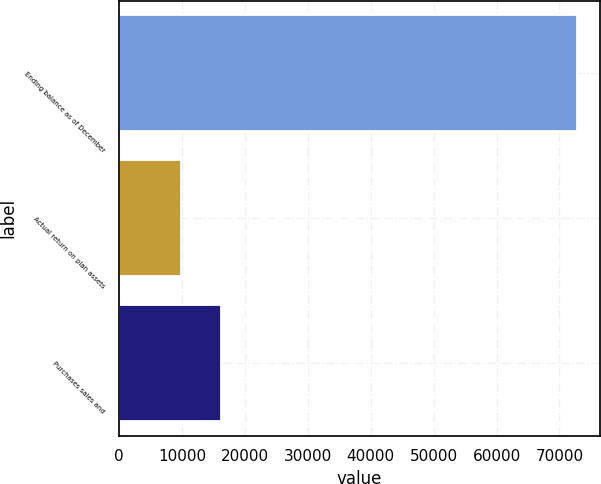Convert chart to OTSL. <chart><loc_0><loc_0><loc_500><loc_500><bar_chart><fcel>Ending balance as of December<fcel>Actual return on plan assets<fcel>Purchases sales and<nl><fcel>72781<fcel>9858<fcel>16150.3<nl></chart> 